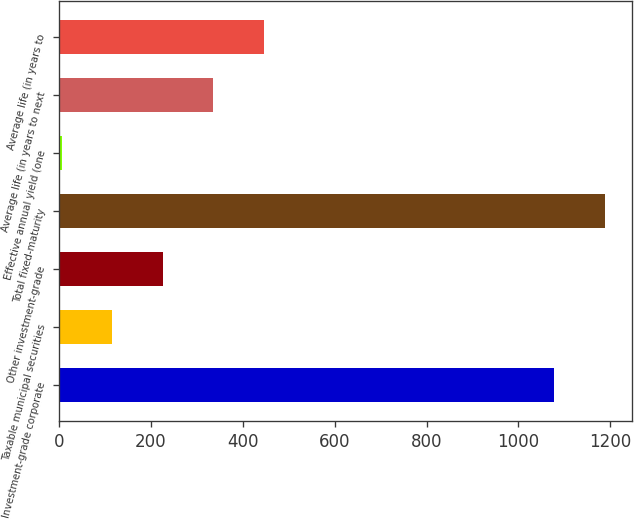<chart> <loc_0><loc_0><loc_500><loc_500><bar_chart><fcel>Investment-grade corporate<fcel>Taxable municipal securities<fcel>Other investment-grade<fcel>Total fixed-maturity<fcel>Effective annual yield (one<fcel>Average life (in years to next<fcel>Average life (in years to<nl><fcel>1078.3<fcel>115.51<fcel>225.37<fcel>1188.15<fcel>5.65<fcel>335.23<fcel>445.09<nl></chart> 